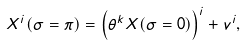<formula> <loc_0><loc_0><loc_500><loc_500>X ^ { i } ( \sigma = \pi ) = \left ( \theta ^ { k } X ( \sigma = 0 ) \right ) ^ { i } + v ^ { i } ,</formula> 